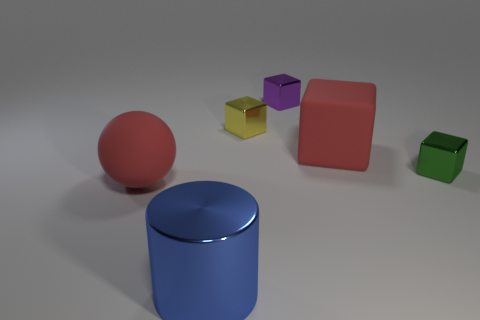Add 4 red blocks. How many objects exist? 10 Subtract all purple cubes. How many cubes are left? 3 Subtract all yellow metal blocks. How many blocks are left? 3 Subtract all balls. How many objects are left? 5 Subtract all cyan balls. How many blue cubes are left? 0 Subtract all big matte balls. Subtract all small green blocks. How many objects are left? 4 Add 4 rubber spheres. How many rubber spheres are left? 5 Add 1 big rubber objects. How many big rubber objects exist? 3 Subtract 1 red balls. How many objects are left? 5 Subtract 1 cylinders. How many cylinders are left? 0 